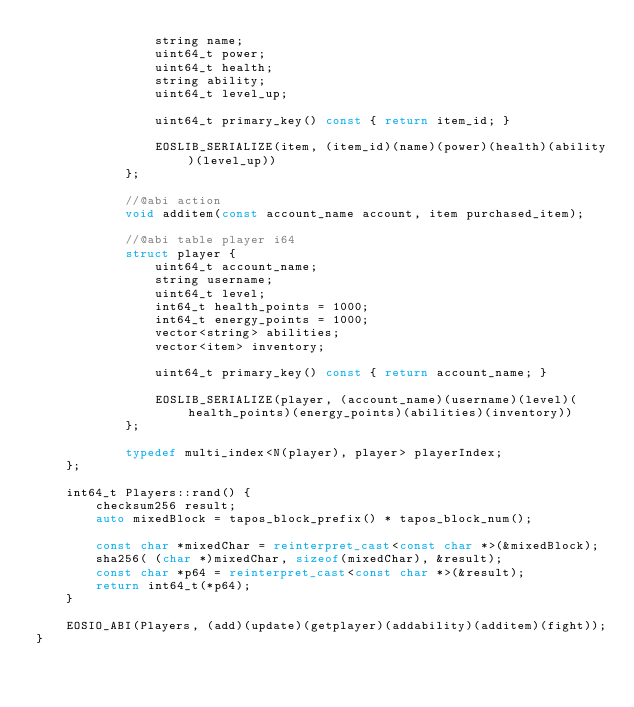Convert code to text. <code><loc_0><loc_0><loc_500><loc_500><_C++_>                string name;
                uint64_t power;
                uint64_t health;
                string ability;
                uint64_t level_up;

                uint64_t primary_key() const { return item_id; }

                EOSLIB_SERIALIZE(item, (item_id)(name)(power)(health)(ability)(level_up))
            };

            //@abi action
            void additem(const account_name account, item purchased_item);

            //@abi table player i64
            struct player {
                uint64_t account_name;
                string username;
                uint64_t level;
                int64_t health_points = 1000;
                int64_t energy_points = 1000;
                vector<string> abilities;
                vector<item> inventory;

                uint64_t primary_key() const { return account_name; }

                EOSLIB_SERIALIZE(player, (account_name)(username)(level)(health_points)(energy_points)(abilities)(inventory))
            };

            typedef multi_index<N(player), player> playerIndex;
    };

    int64_t Players::rand() {
        checksum256 result;
        auto mixedBlock = tapos_block_prefix() * tapos_block_num();

        const char *mixedChar = reinterpret_cast<const char *>(&mixedBlock);
        sha256( (char *)mixedChar, sizeof(mixedChar), &result);
        const char *p64 = reinterpret_cast<const char *>(&result);
        return int64_t(*p64);
    }

    EOSIO_ABI(Players, (add)(update)(getplayer)(addability)(additem)(fight));
}
</code> 